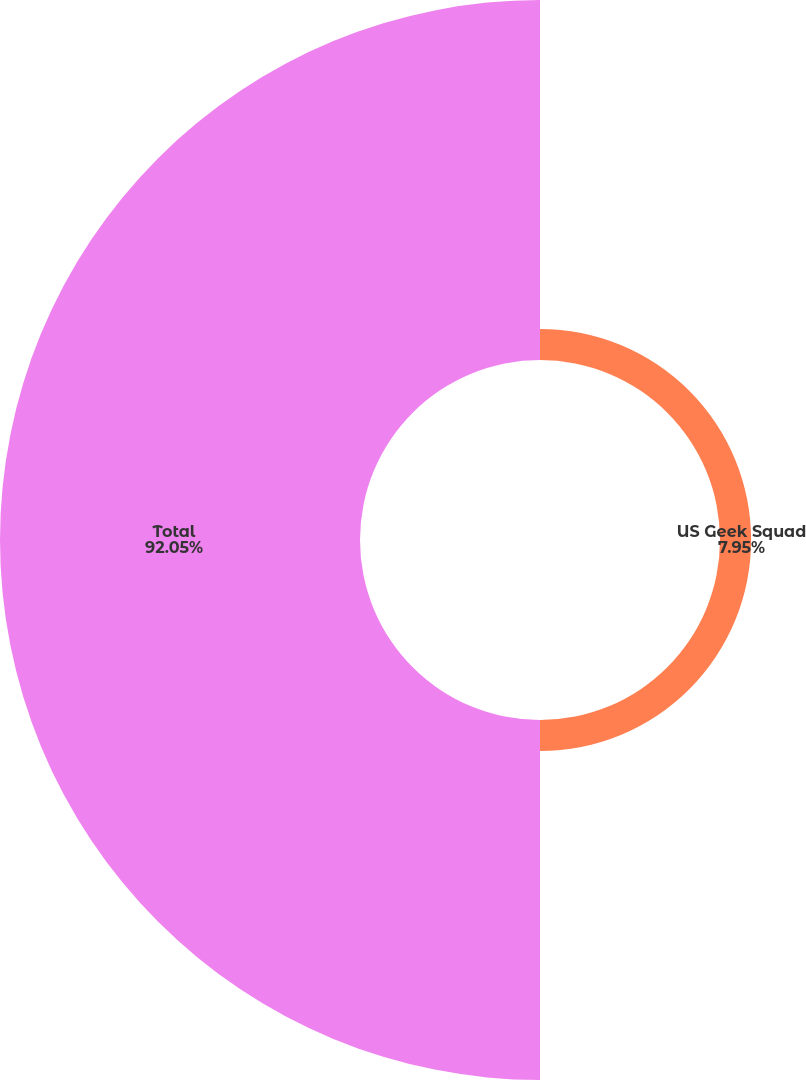<chart> <loc_0><loc_0><loc_500><loc_500><pie_chart><fcel>US Geek Squad<fcel>Total<nl><fcel>7.95%<fcel>92.05%<nl></chart> 